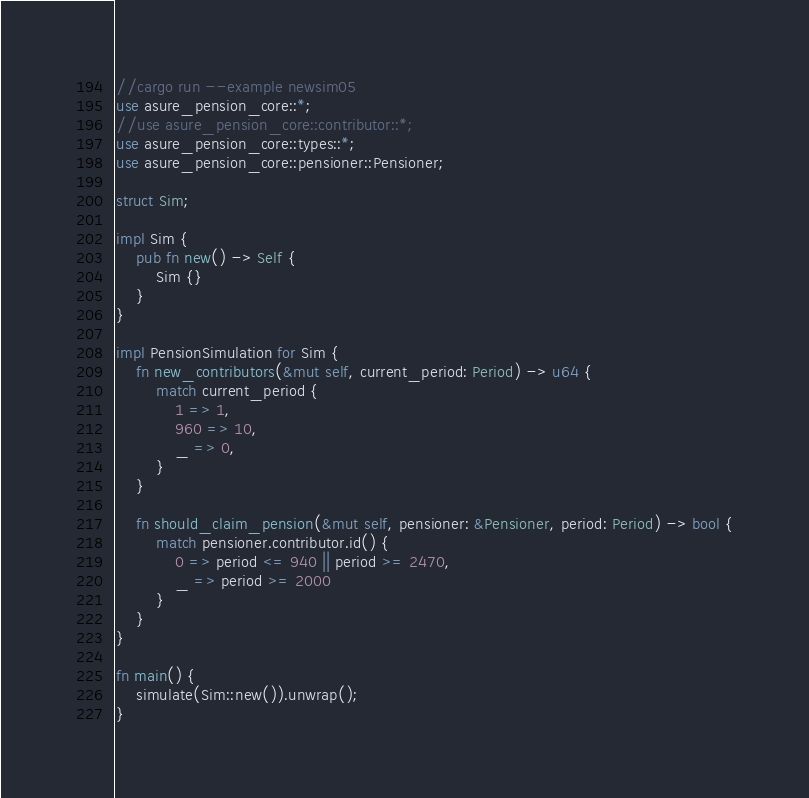Convert code to text. <code><loc_0><loc_0><loc_500><loc_500><_Rust_>//cargo run --example newsim05
use asure_pension_core::*;
//use asure_pension_core::contributor::*;
use asure_pension_core::types::*;
use asure_pension_core::pensioner::Pensioner;

struct Sim;

impl Sim {
    pub fn new() -> Self {
        Sim {}
    }
}

impl PensionSimulation for Sim {
    fn new_contributors(&mut self, current_period: Period) -> u64 {
        match current_period {
            1 => 1,
            960 => 10,
            _ => 0,
        }
    }

    fn should_claim_pension(&mut self, pensioner: &Pensioner, period: Period) -> bool {
        match pensioner.contributor.id() {
            0 => period <= 940 || period >= 2470,
            _ => period >= 2000
        }
    }
}

fn main() {
    simulate(Sim::new()).unwrap();
}
</code> 